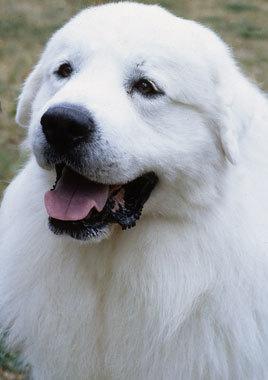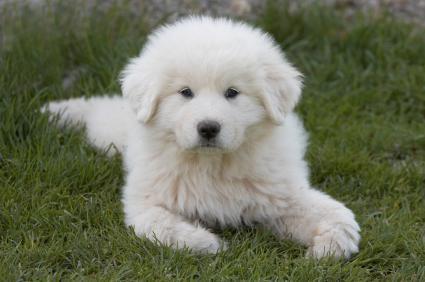The first image is the image on the left, the second image is the image on the right. Considering the images on both sides, is "The image on the left contains only the dog's head and chest." valid? Answer yes or no. Yes. 